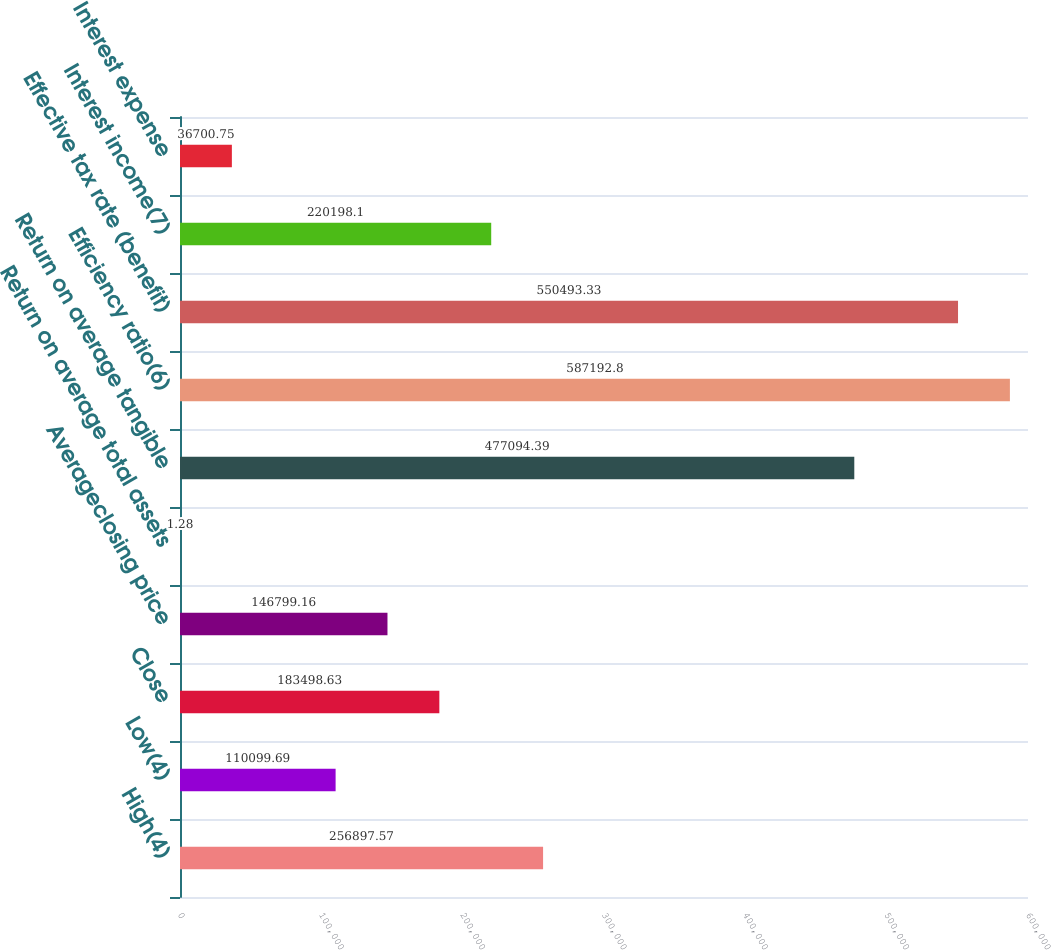<chart> <loc_0><loc_0><loc_500><loc_500><bar_chart><fcel>High(4)<fcel>Low(4)<fcel>Close<fcel>Averageclosing price<fcel>Return on average total assets<fcel>Return on average tangible<fcel>Efficiency ratio(6)<fcel>Effective tax rate (benefit)<fcel>Interest income(7)<fcel>Interest expense<nl><fcel>256898<fcel>110100<fcel>183499<fcel>146799<fcel>1.28<fcel>477094<fcel>587193<fcel>550493<fcel>220198<fcel>36700.8<nl></chart> 